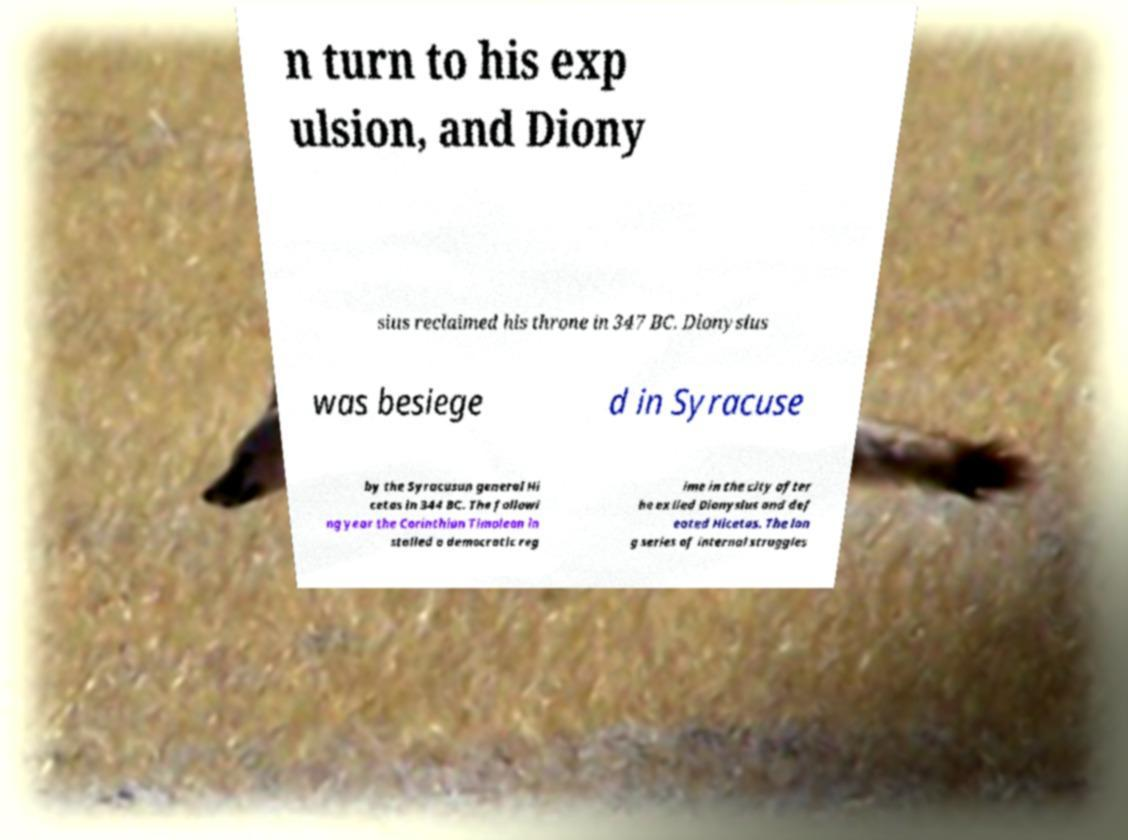Please read and relay the text visible in this image. What does it say? n turn to his exp ulsion, and Diony sius reclaimed his throne in 347 BC. Dionysius was besiege d in Syracuse by the Syracusan general Hi cetas in 344 BC. The followi ng year the Corinthian Timoleon in stalled a democratic reg ime in the city after he exiled Dionysius and def eated Hicetas. The lon g series of internal struggles 